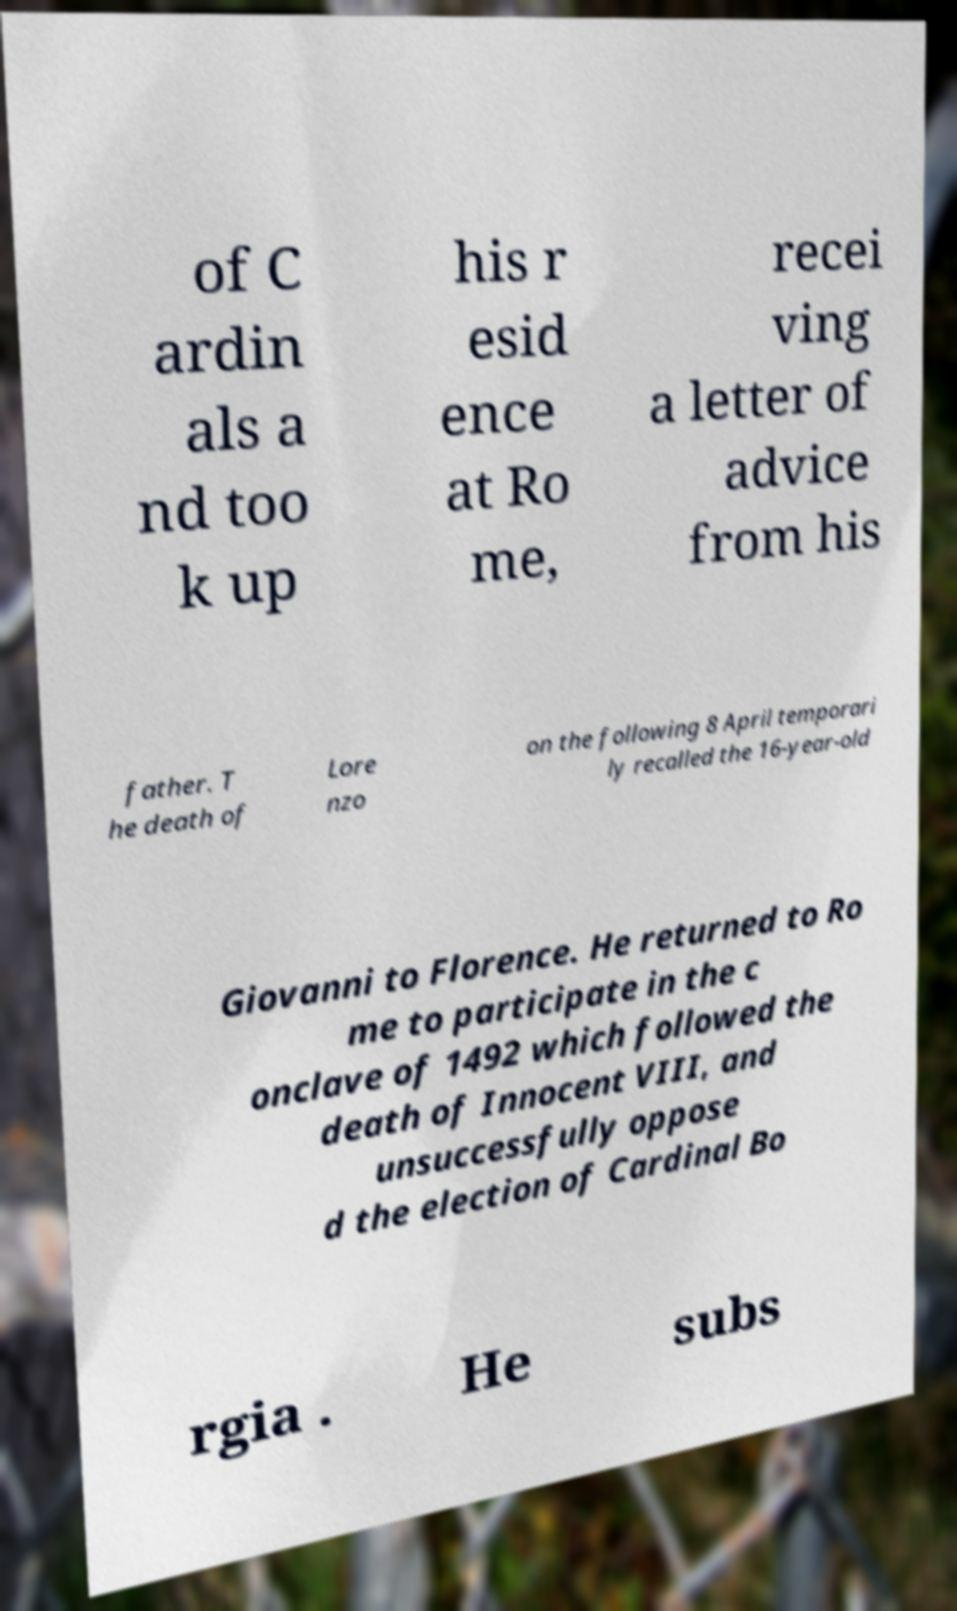Please identify and transcribe the text found in this image. of C ardin als a nd too k up his r esid ence at Ro me, recei ving a letter of advice from his father. T he death of Lore nzo on the following 8 April temporari ly recalled the 16-year-old Giovanni to Florence. He returned to Ro me to participate in the c onclave of 1492 which followed the death of Innocent VIII, and unsuccessfully oppose d the election of Cardinal Bo rgia . He subs 